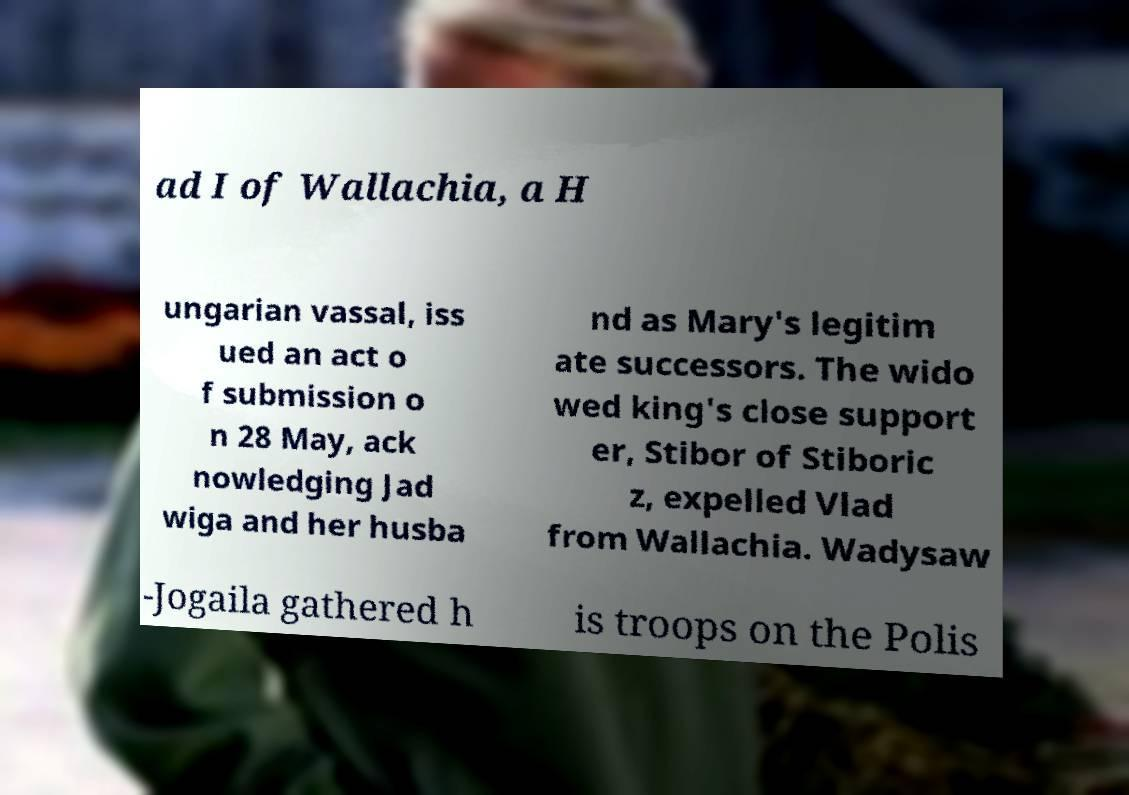There's text embedded in this image that I need extracted. Can you transcribe it verbatim? ad I of Wallachia, a H ungarian vassal, iss ued an act o f submission o n 28 May, ack nowledging Jad wiga and her husba nd as Mary's legitim ate successors. The wido wed king's close support er, Stibor of Stiboric z, expelled Vlad from Wallachia. Wadysaw -Jogaila gathered h is troops on the Polis 